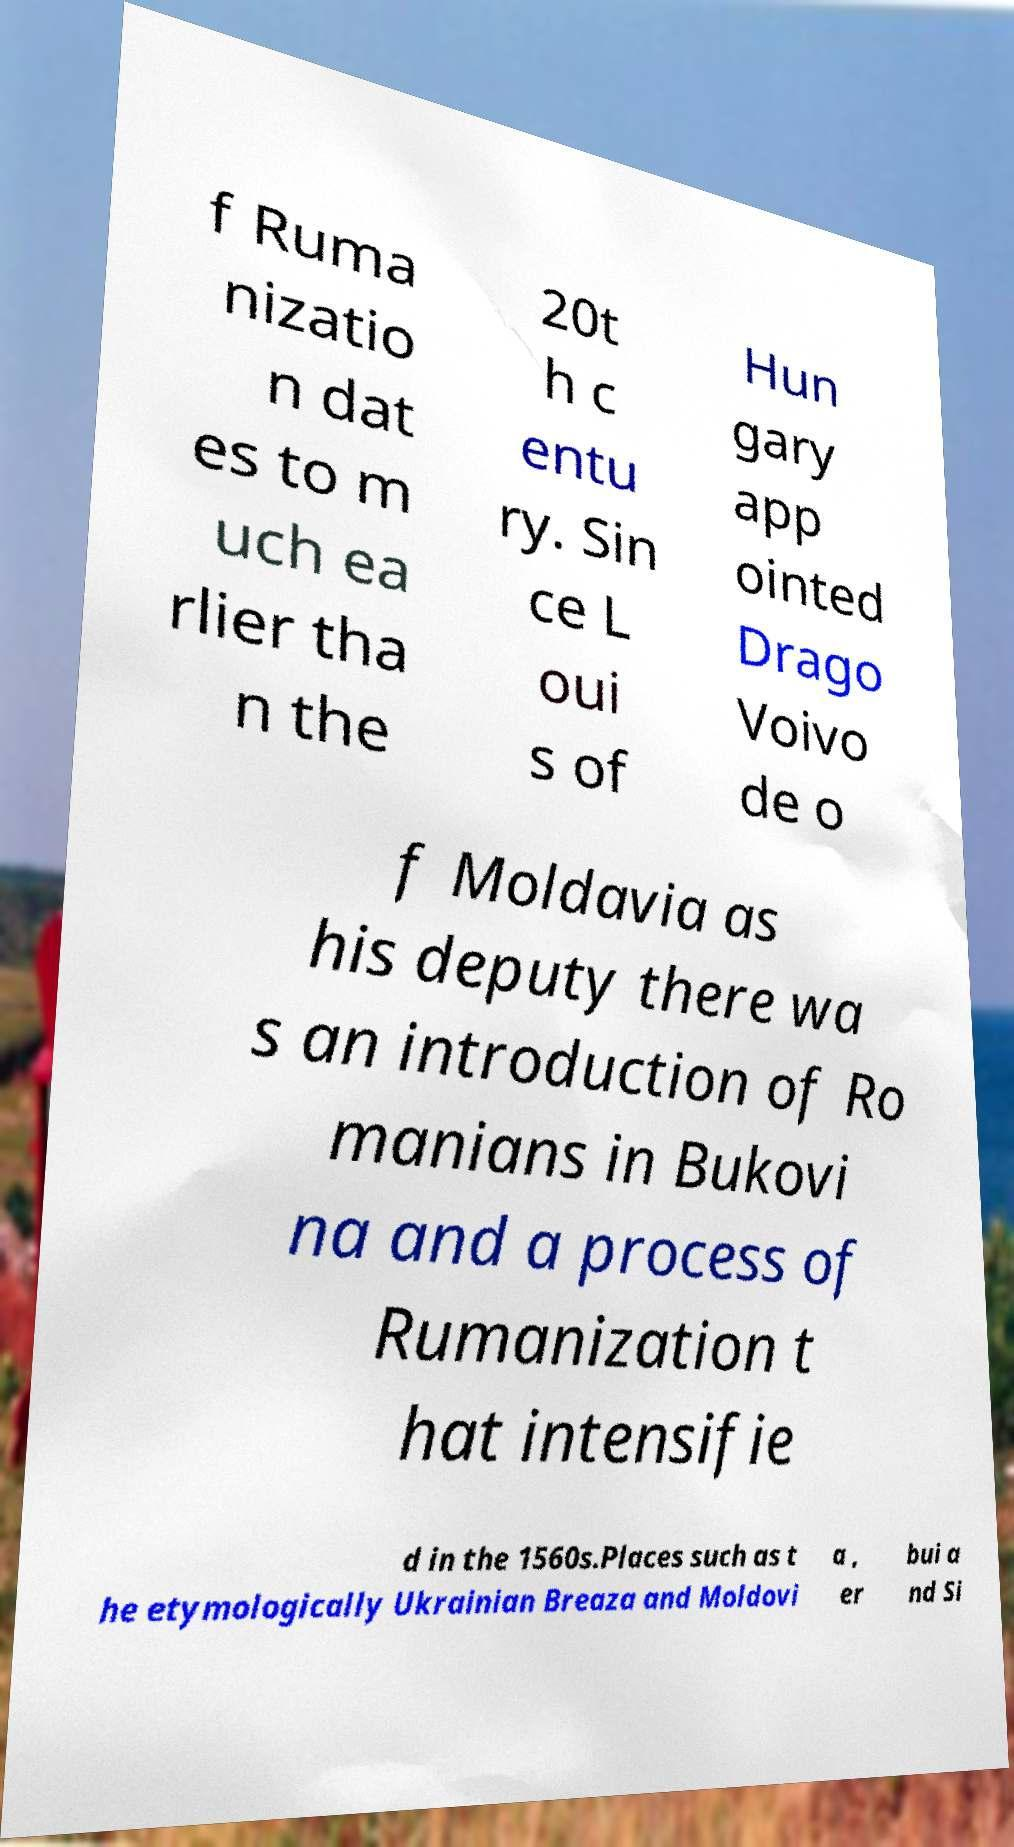There's text embedded in this image that I need extracted. Can you transcribe it verbatim? f Ruma nizatio n dat es to m uch ea rlier tha n the 20t h c entu ry. Sin ce L oui s of Hun gary app ointed Drago Voivo de o f Moldavia as his deputy there wa s an introduction of Ro manians in Bukovi na and a process of Rumanization t hat intensifie d in the 1560s.Places such as t he etymologically Ukrainian Breaza and Moldovi a , er bui a nd Si 